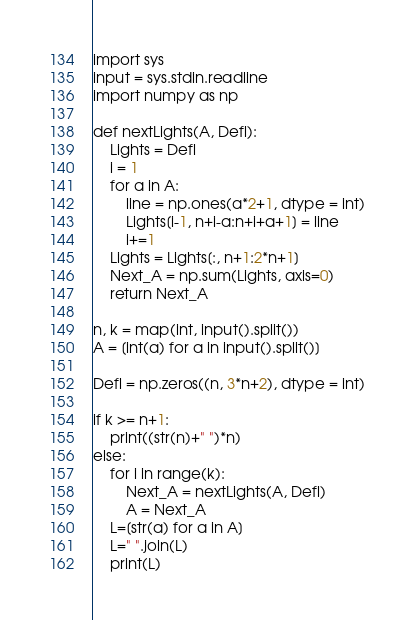<code> <loc_0><loc_0><loc_500><loc_500><_Python_>import sys
input = sys.stdin.readline
import numpy as np

def nextLights(A, Defl):
    Lights = Defl
    i = 1
    for a in A:
        line = np.ones(a*2+1, dtype = int)
        Lights[i-1, n+i-a:n+i+a+1] = line
        i+=1
    Lights = Lights[:, n+1:2*n+1]
    Next_A = np.sum(Lights, axis=0)
    return Next_A

n, k = map(int, input().split())
A = [int(a) for a in input().split()]

Defl = np.zeros((n, 3*n+2), dtype = int)

if k >= n+1:
    print((str(n)+" ")*n)
else:
    for i in range(k):
        Next_A = nextLights(A, Defl)
        A = Next_A
    L=[str(a) for a in A]
    L=" ".join(L)
    print(L)
</code> 